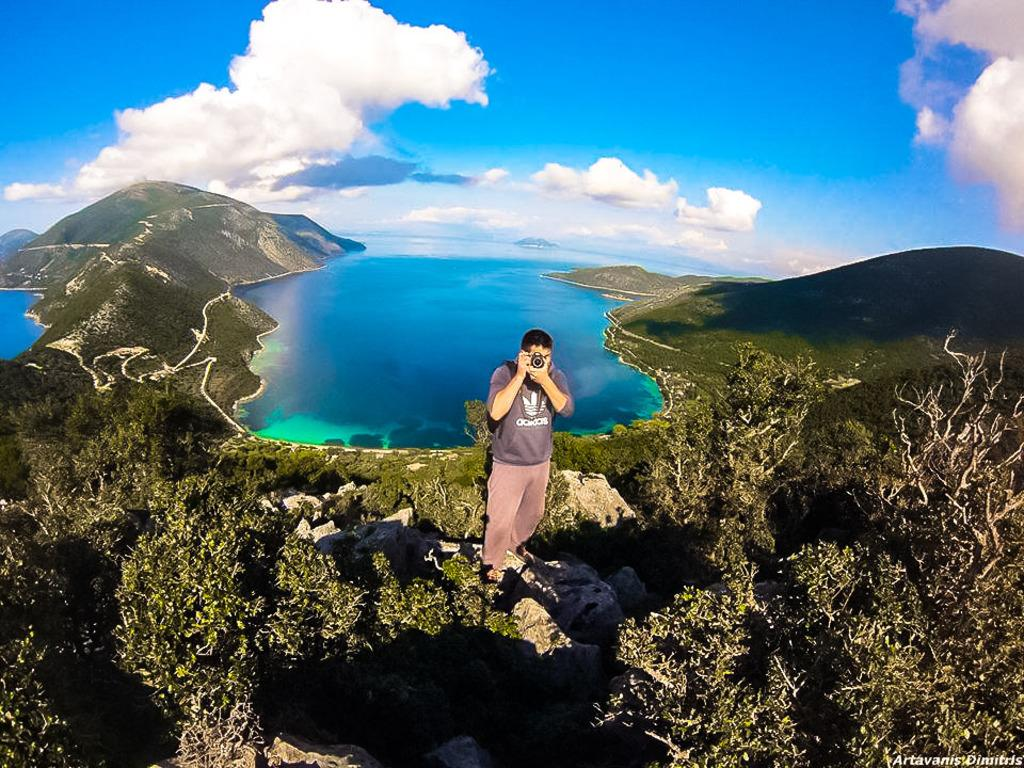What is the man in the image holding? The man is holding a camera in the image. Where is the man standing in the image? The man is standing on a rock in the image. What type of natural environment can be seen in the image? Trees, water, mountains, and the sky are visible in the image. Can you describe the sky in the image? The sky is visible in the background of the image, and clouds are present. What type of pollution can be seen in the image? There is no pollution visible in the image. Can you describe the spot on the man's shirt in the image? There is no spot visible on the man's shirt in the image. 